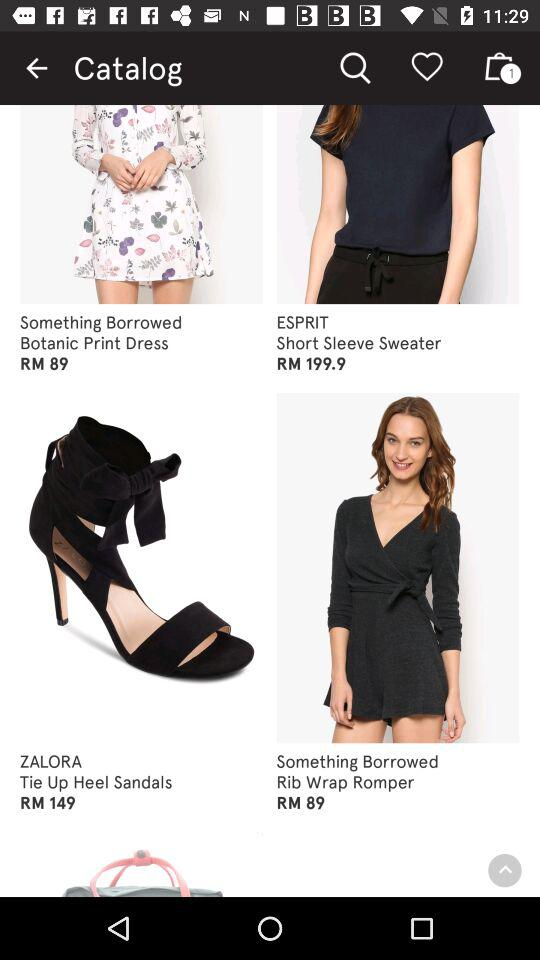What is the price of the botanic print dress? The price is RM 89. 